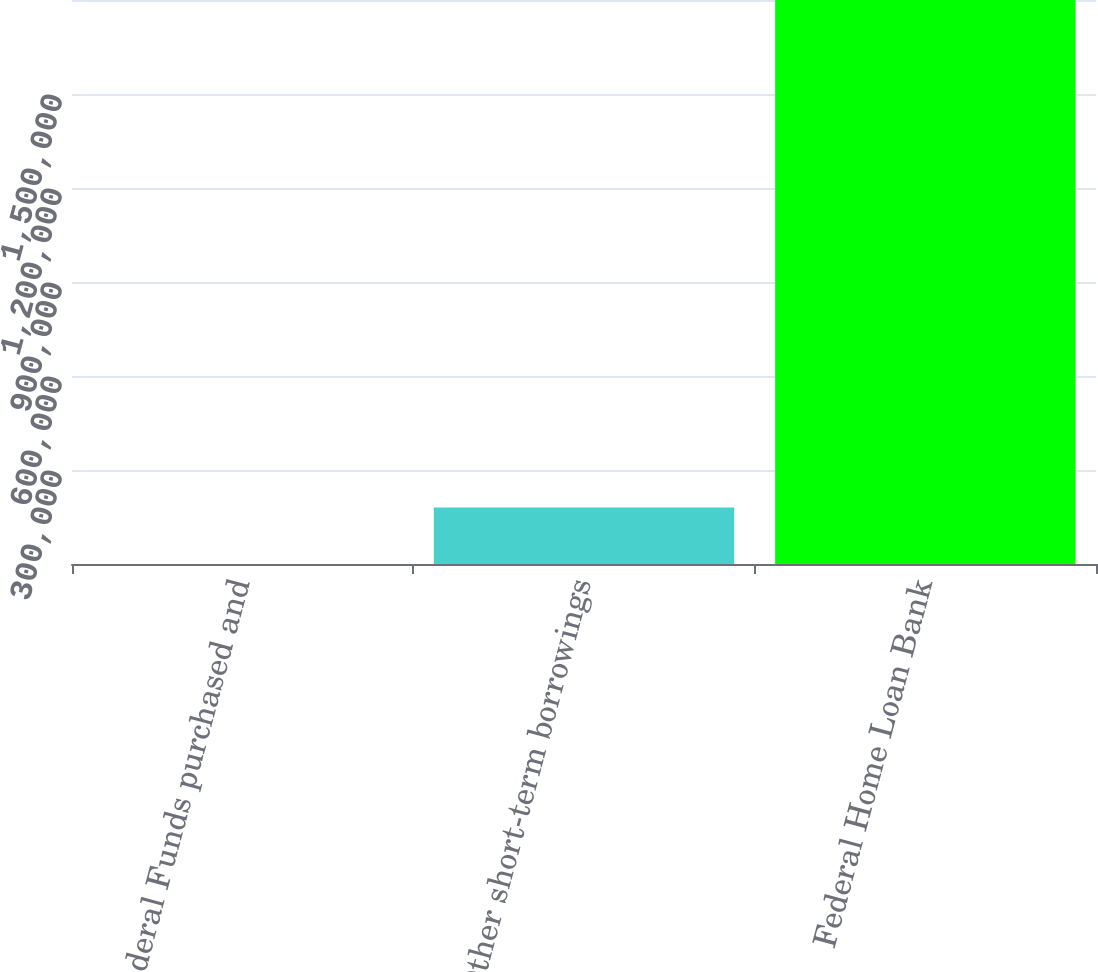Convert chart to OTSL. <chart><loc_0><loc_0><loc_500><loc_500><bar_chart><fcel>Federal Funds purchased and<fcel>Other short-term borrowings<fcel>Federal Home Loan Bank<nl><fcel>0.06<fcel>180000<fcel>1.8e+06<nl></chart> 